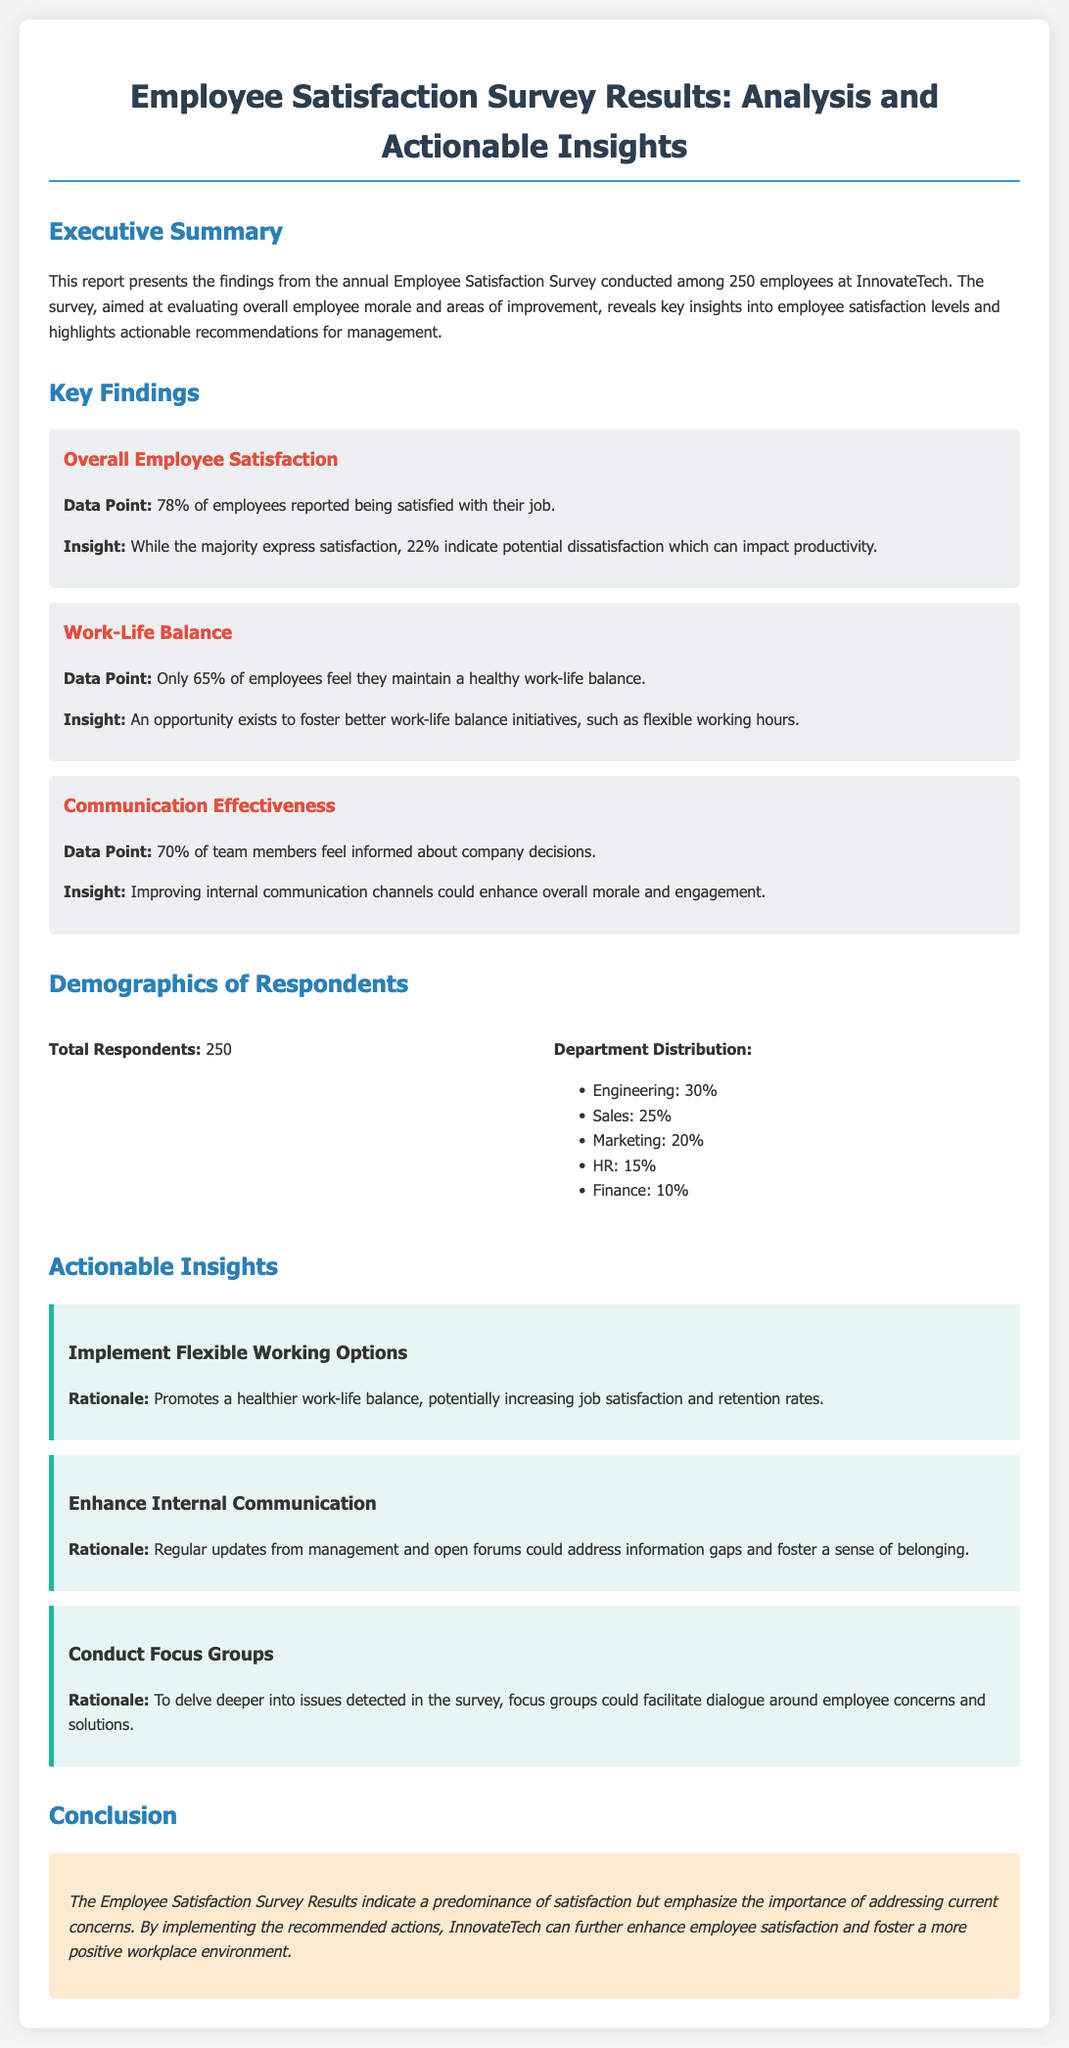What percentage of employees reported being satisfied with their job? The document states that 78% of employees reported being satisfied, indicating the overall employee satisfaction rate.
Answer: 78% What percent of employees feel they maintain a healthy work-life balance? According to the document, only 65% of employees feel they maintain a healthy work-life balance, which highlights a potential area for improvement.
Answer: 65% What is one of the key findings related to communication effectiveness? The document mentions that 70% of team members feel informed about company decisions, which is important for overall morale.
Answer: 70% What actionable insight is recommended to enhance internal communication? The document suggests that regular updates from management and open forums could address information gaps and foster a sense of belonging.
Answer: Enhance Internal Communication How many total respondents participated in the survey? The document specifies that there were 250 total respondents who participated in the Employee Satisfaction Survey.
Answer: 250 What is the predominant department distribution percentage for Engineering? The document states that the Engineering department constitutes 30% of the respondents, representing the largest group.
Answer: 30% What is the overall conclusion regarding employee satisfaction at InnovateTech? The conclusion emphasizes the need for addressing current concerns while noting the predominance of satisfaction among employees.
Answer: Predominance of satisfaction What does the report identify as a potential consequence of the 22% dissatisfaction? The document indicates that potential dissatisfaction could impact productivity, which is a significant concern for management.
Answer: Impact productivity 